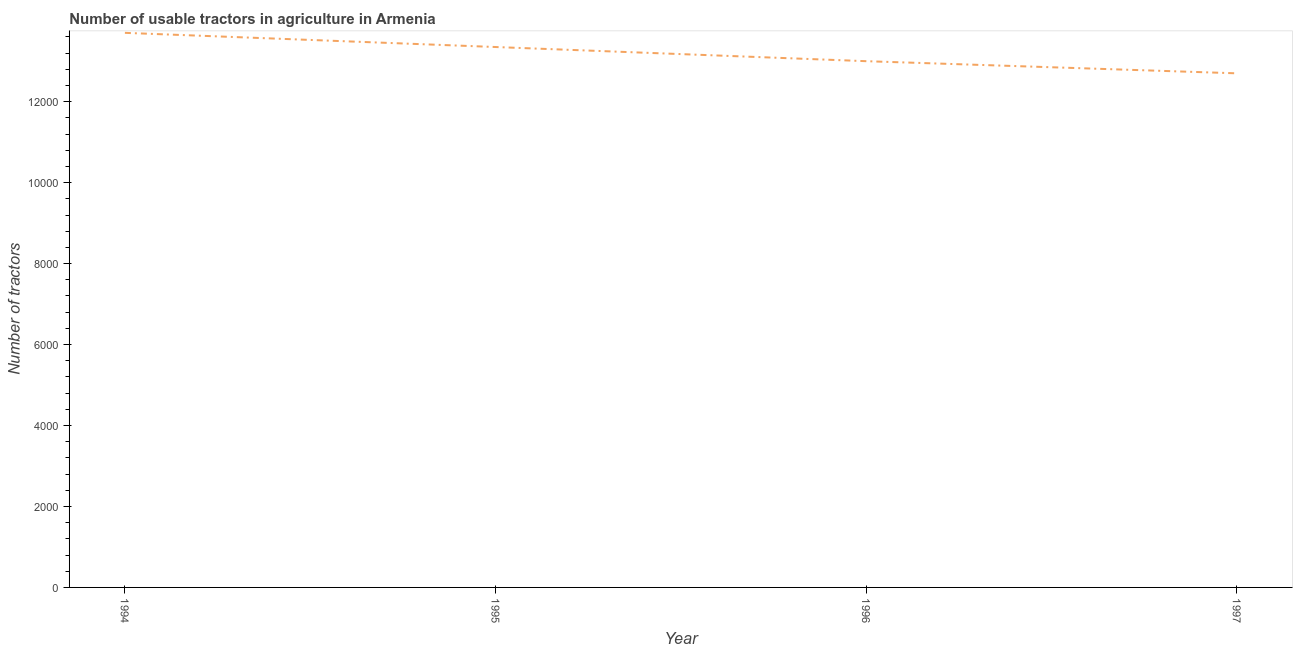What is the number of tractors in 1997?
Provide a succinct answer. 1.27e+04. Across all years, what is the maximum number of tractors?
Your answer should be very brief. 1.37e+04. Across all years, what is the minimum number of tractors?
Your answer should be compact. 1.27e+04. In which year was the number of tractors minimum?
Your answer should be compact. 1997. What is the sum of the number of tractors?
Your response must be concise. 5.28e+04. What is the difference between the number of tractors in 1994 and 1995?
Your answer should be compact. 350. What is the average number of tractors per year?
Provide a short and direct response. 1.32e+04. What is the median number of tractors?
Ensure brevity in your answer.  1.32e+04. What is the ratio of the number of tractors in 1995 to that in 1997?
Your answer should be compact. 1.05. Is the number of tractors in 1994 less than that in 1996?
Give a very brief answer. No. What is the difference between the highest and the second highest number of tractors?
Ensure brevity in your answer.  350. Is the sum of the number of tractors in 1995 and 1997 greater than the maximum number of tractors across all years?
Provide a succinct answer. Yes. What is the difference between the highest and the lowest number of tractors?
Provide a short and direct response. 1000. In how many years, is the number of tractors greater than the average number of tractors taken over all years?
Offer a very short reply. 2. Does the number of tractors monotonically increase over the years?
Ensure brevity in your answer.  No. How many years are there in the graph?
Your response must be concise. 4. What is the difference between two consecutive major ticks on the Y-axis?
Offer a terse response. 2000. What is the title of the graph?
Provide a short and direct response. Number of usable tractors in agriculture in Armenia. What is the label or title of the Y-axis?
Offer a very short reply. Number of tractors. What is the Number of tractors in 1994?
Offer a terse response. 1.37e+04. What is the Number of tractors in 1995?
Your response must be concise. 1.34e+04. What is the Number of tractors in 1996?
Offer a very short reply. 1.30e+04. What is the Number of tractors in 1997?
Provide a short and direct response. 1.27e+04. What is the difference between the Number of tractors in 1994 and 1995?
Make the answer very short. 350. What is the difference between the Number of tractors in 1994 and 1996?
Offer a terse response. 700. What is the difference between the Number of tractors in 1995 and 1996?
Offer a terse response. 350. What is the difference between the Number of tractors in 1995 and 1997?
Your response must be concise. 650. What is the difference between the Number of tractors in 1996 and 1997?
Provide a short and direct response. 300. What is the ratio of the Number of tractors in 1994 to that in 1995?
Ensure brevity in your answer.  1.03. What is the ratio of the Number of tractors in 1994 to that in 1996?
Ensure brevity in your answer.  1.05. What is the ratio of the Number of tractors in 1994 to that in 1997?
Provide a short and direct response. 1.08. What is the ratio of the Number of tractors in 1995 to that in 1997?
Keep it short and to the point. 1.05. What is the ratio of the Number of tractors in 1996 to that in 1997?
Offer a terse response. 1.02. 